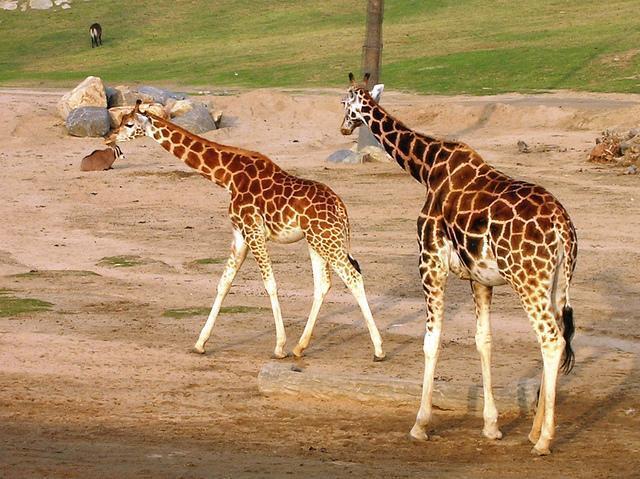How many giraffes are there?
Give a very brief answer. 2. How many giraffes are visible?
Give a very brief answer. 2. 